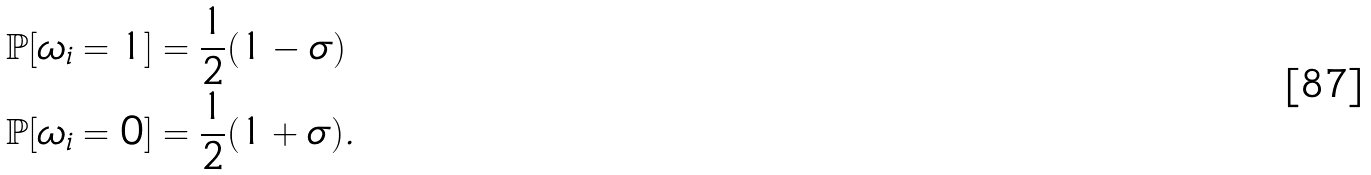Convert formula to latex. <formula><loc_0><loc_0><loc_500><loc_500>\mathbb { P } [ \omega _ { i } = 1 ] & = \frac { 1 } { 2 } ( 1 - \sigma ) \\ \mathbb { P } [ \omega _ { i } = 0 ] & = \frac { 1 } { 2 } ( 1 + \sigma ) .</formula> 